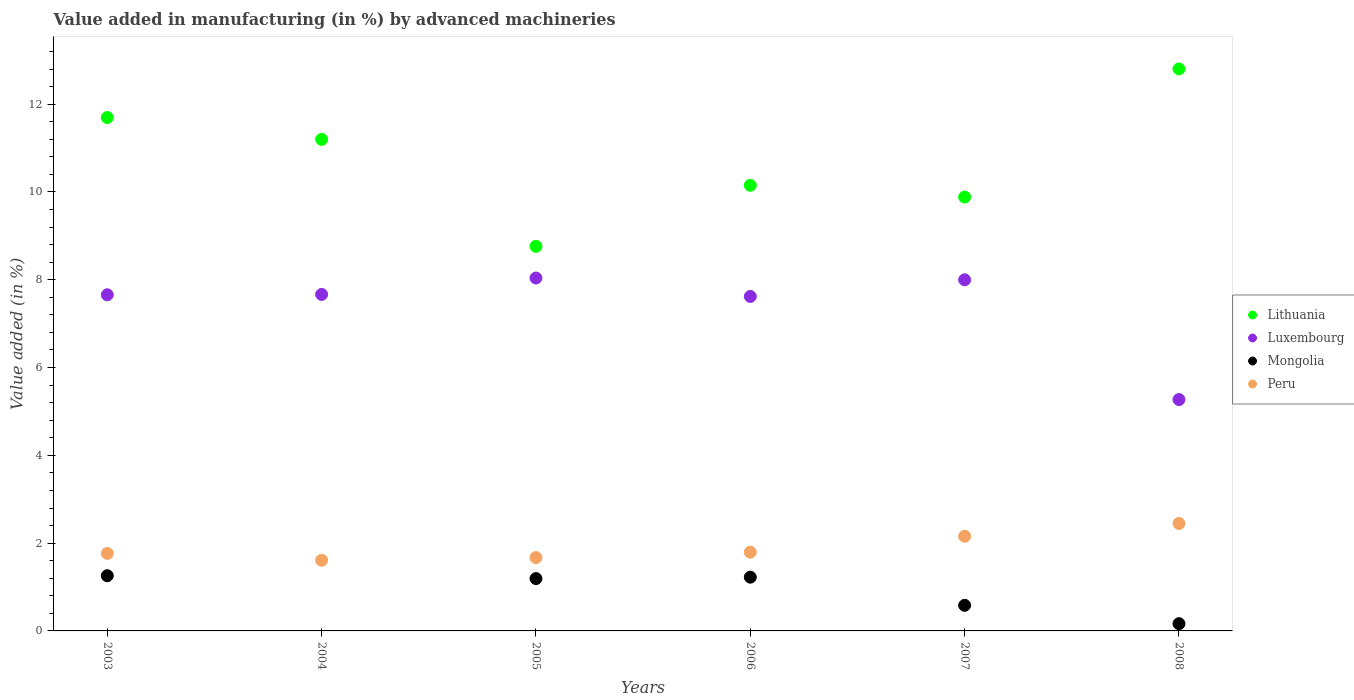What is the percentage of value added in manufacturing by advanced machineries in Lithuania in 2007?
Provide a short and direct response. 9.88. Across all years, what is the maximum percentage of value added in manufacturing by advanced machineries in Mongolia?
Offer a very short reply. 1.26. Across all years, what is the minimum percentage of value added in manufacturing by advanced machineries in Peru?
Make the answer very short. 1.61. In which year was the percentage of value added in manufacturing by advanced machineries in Peru maximum?
Make the answer very short. 2008. What is the total percentage of value added in manufacturing by advanced machineries in Mongolia in the graph?
Give a very brief answer. 4.42. What is the difference between the percentage of value added in manufacturing by advanced machineries in Luxembourg in 2004 and that in 2005?
Keep it short and to the point. -0.37. What is the difference between the percentage of value added in manufacturing by advanced machineries in Mongolia in 2006 and the percentage of value added in manufacturing by advanced machineries in Peru in 2007?
Your answer should be compact. -0.93. What is the average percentage of value added in manufacturing by advanced machineries in Peru per year?
Give a very brief answer. 1.91. In the year 2005, what is the difference between the percentage of value added in manufacturing by advanced machineries in Luxembourg and percentage of value added in manufacturing by advanced machineries in Lithuania?
Make the answer very short. -0.72. In how many years, is the percentage of value added in manufacturing by advanced machineries in Luxembourg greater than 7.6 %?
Offer a terse response. 5. What is the ratio of the percentage of value added in manufacturing by advanced machineries in Luxembourg in 2004 to that in 2005?
Keep it short and to the point. 0.95. Is the percentage of value added in manufacturing by advanced machineries in Mongolia in 2005 less than that in 2006?
Make the answer very short. Yes. Is the difference between the percentage of value added in manufacturing by advanced machineries in Luxembourg in 2003 and 2005 greater than the difference between the percentage of value added in manufacturing by advanced machineries in Lithuania in 2003 and 2005?
Provide a succinct answer. No. What is the difference between the highest and the second highest percentage of value added in manufacturing by advanced machineries in Luxembourg?
Offer a terse response. 0.04. What is the difference between the highest and the lowest percentage of value added in manufacturing by advanced machineries in Mongolia?
Provide a succinct answer. 1.26. Is the percentage of value added in manufacturing by advanced machineries in Peru strictly greater than the percentage of value added in manufacturing by advanced machineries in Lithuania over the years?
Your response must be concise. No. What is the difference between two consecutive major ticks on the Y-axis?
Offer a terse response. 2. Does the graph contain any zero values?
Ensure brevity in your answer.  Yes. Where does the legend appear in the graph?
Your answer should be very brief. Center right. How are the legend labels stacked?
Give a very brief answer. Vertical. What is the title of the graph?
Make the answer very short. Value added in manufacturing (in %) by advanced machineries. Does "Pacific island small states" appear as one of the legend labels in the graph?
Make the answer very short. No. What is the label or title of the X-axis?
Give a very brief answer. Years. What is the label or title of the Y-axis?
Your answer should be compact. Value added (in %). What is the Value added (in %) of Lithuania in 2003?
Your response must be concise. 11.7. What is the Value added (in %) in Luxembourg in 2003?
Ensure brevity in your answer.  7.66. What is the Value added (in %) in Mongolia in 2003?
Offer a very short reply. 1.26. What is the Value added (in %) in Peru in 2003?
Keep it short and to the point. 1.77. What is the Value added (in %) in Lithuania in 2004?
Provide a short and direct response. 11.2. What is the Value added (in %) in Luxembourg in 2004?
Your answer should be compact. 7.67. What is the Value added (in %) of Peru in 2004?
Your response must be concise. 1.61. What is the Value added (in %) in Lithuania in 2005?
Your answer should be compact. 8.76. What is the Value added (in %) of Luxembourg in 2005?
Make the answer very short. 8.04. What is the Value added (in %) in Mongolia in 2005?
Provide a short and direct response. 1.19. What is the Value added (in %) of Peru in 2005?
Ensure brevity in your answer.  1.67. What is the Value added (in %) in Lithuania in 2006?
Provide a short and direct response. 10.15. What is the Value added (in %) of Luxembourg in 2006?
Offer a very short reply. 7.62. What is the Value added (in %) in Mongolia in 2006?
Offer a very short reply. 1.22. What is the Value added (in %) in Peru in 2006?
Your answer should be very brief. 1.79. What is the Value added (in %) in Lithuania in 2007?
Your response must be concise. 9.88. What is the Value added (in %) in Luxembourg in 2007?
Offer a terse response. 8. What is the Value added (in %) in Mongolia in 2007?
Offer a terse response. 0.58. What is the Value added (in %) in Peru in 2007?
Your answer should be compact. 2.16. What is the Value added (in %) of Lithuania in 2008?
Keep it short and to the point. 12.8. What is the Value added (in %) of Luxembourg in 2008?
Give a very brief answer. 5.27. What is the Value added (in %) of Mongolia in 2008?
Make the answer very short. 0.17. What is the Value added (in %) of Peru in 2008?
Offer a terse response. 2.45. Across all years, what is the maximum Value added (in %) of Lithuania?
Make the answer very short. 12.8. Across all years, what is the maximum Value added (in %) in Luxembourg?
Keep it short and to the point. 8.04. Across all years, what is the maximum Value added (in %) in Mongolia?
Your answer should be compact. 1.26. Across all years, what is the maximum Value added (in %) in Peru?
Provide a short and direct response. 2.45. Across all years, what is the minimum Value added (in %) in Lithuania?
Offer a very short reply. 8.76. Across all years, what is the minimum Value added (in %) of Luxembourg?
Ensure brevity in your answer.  5.27. Across all years, what is the minimum Value added (in %) in Mongolia?
Provide a short and direct response. 0. Across all years, what is the minimum Value added (in %) in Peru?
Your answer should be compact. 1.61. What is the total Value added (in %) of Lithuania in the graph?
Offer a very short reply. 64.49. What is the total Value added (in %) in Luxembourg in the graph?
Keep it short and to the point. 44.25. What is the total Value added (in %) in Mongolia in the graph?
Your response must be concise. 4.42. What is the total Value added (in %) of Peru in the graph?
Your answer should be compact. 11.45. What is the difference between the Value added (in %) in Lithuania in 2003 and that in 2004?
Give a very brief answer. 0.5. What is the difference between the Value added (in %) of Luxembourg in 2003 and that in 2004?
Give a very brief answer. -0.01. What is the difference between the Value added (in %) in Peru in 2003 and that in 2004?
Your answer should be compact. 0.16. What is the difference between the Value added (in %) in Lithuania in 2003 and that in 2005?
Your response must be concise. 2.93. What is the difference between the Value added (in %) of Luxembourg in 2003 and that in 2005?
Give a very brief answer. -0.38. What is the difference between the Value added (in %) in Mongolia in 2003 and that in 2005?
Provide a succinct answer. 0.07. What is the difference between the Value added (in %) in Peru in 2003 and that in 2005?
Give a very brief answer. 0.09. What is the difference between the Value added (in %) of Lithuania in 2003 and that in 2006?
Provide a short and direct response. 1.54. What is the difference between the Value added (in %) in Luxembourg in 2003 and that in 2006?
Ensure brevity in your answer.  0.04. What is the difference between the Value added (in %) in Mongolia in 2003 and that in 2006?
Your response must be concise. 0.03. What is the difference between the Value added (in %) in Peru in 2003 and that in 2006?
Offer a very short reply. -0.03. What is the difference between the Value added (in %) of Lithuania in 2003 and that in 2007?
Offer a terse response. 1.81. What is the difference between the Value added (in %) in Luxembourg in 2003 and that in 2007?
Your answer should be very brief. -0.34. What is the difference between the Value added (in %) in Mongolia in 2003 and that in 2007?
Your answer should be very brief. 0.67. What is the difference between the Value added (in %) of Peru in 2003 and that in 2007?
Your response must be concise. -0.39. What is the difference between the Value added (in %) in Lithuania in 2003 and that in 2008?
Ensure brevity in your answer.  -1.11. What is the difference between the Value added (in %) of Luxembourg in 2003 and that in 2008?
Provide a succinct answer. 2.39. What is the difference between the Value added (in %) in Mongolia in 2003 and that in 2008?
Give a very brief answer. 1.09. What is the difference between the Value added (in %) of Peru in 2003 and that in 2008?
Make the answer very short. -0.68. What is the difference between the Value added (in %) in Lithuania in 2004 and that in 2005?
Provide a short and direct response. 2.44. What is the difference between the Value added (in %) in Luxembourg in 2004 and that in 2005?
Provide a succinct answer. -0.37. What is the difference between the Value added (in %) of Peru in 2004 and that in 2005?
Give a very brief answer. -0.06. What is the difference between the Value added (in %) in Lithuania in 2004 and that in 2006?
Ensure brevity in your answer.  1.05. What is the difference between the Value added (in %) in Luxembourg in 2004 and that in 2006?
Your answer should be compact. 0.05. What is the difference between the Value added (in %) of Peru in 2004 and that in 2006?
Give a very brief answer. -0.18. What is the difference between the Value added (in %) of Lithuania in 2004 and that in 2007?
Your answer should be compact. 1.31. What is the difference between the Value added (in %) of Luxembourg in 2004 and that in 2007?
Provide a succinct answer. -0.33. What is the difference between the Value added (in %) of Peru in 2004 and that in 2007?
Offer a terse response. -0.55. What is the difference between the Value added (in %) of Lithuania in 2004 and that in 2008?
Ensure brevity in your answer.  -1.6. What is the difference between the Value added (in %) of Luxembourg in 2004 and that in 2008?
Offer a terse response. 2.39. What is the difference between the Value added (in %) of Peru in 2004 and that in 2008?
Provide a succinct answer. -0.84. What is the difference between the Value added (in %) of Lithuania in 2005 and that in 2006?
Make the answer very short. -1.39. What is the difference between the Value added (in %) in Luxembourg in 2005 and that in 2006?
Your answer should be compact. 0.42. What is the difference between the Value added (in %) of Mongolia in 2005 and that in 2006?
Offer a terse response. -0.03. What is the difference between the Value added (in %) in Peru in 2005 and that in 2006?
Provide a short and direct response. -0.12. What is the difference between the Value added (in %) of Lithuania in 2005 and that in 2007?
Your answer should be compact. -1.12. What is the difference between the Value added (in %) of Luxembourg in 2005 and that in 2007?
Offer a very short reply. 0.04. What is the difference between the Value added (in %) in Mongolia in 2005 and that in 2007?
Offer a terse response. 0.61. What is the difference between the Value added (in %) in Peru in 2005 and that in 2007?
Your answer should be very brief. -0.49. What is the difference between the Value added (in %) in Lithuania in 2005 and that in 2008?
Your answer should be very brief. -4.04. What is the difference between the Value added (in %) of Luxembourg in 2005 and that in 2008?
Your answer should be compact. 2.77. What is the difference between the Value added (in %) in Mongolia in 2005 and that in 2008?
Ensure brevity in your answer.  1.03. What is the difference between the Value added (in %) in Peru in 2005 and that in 2008?
Make the answer very short. -0.78. What is the difference between the Value added (in %) in Lithuania in 2006 and that in 2007?
Your answer should be very brief. 0.27. What is the difference between the Value added (in %) in Luxembourg in 2006 and that in 2007?
Give a very brief answer. -0.38. What is the difference between the Value added (in %) of Mongolia in 2006 and that in 2007?
Your response must be concise. 0.64. What is the difference between the Value added (in %) in Peru in 2006 and that in 2007?
Ensure brevity in your answer.  -0.36. What is the difference between the Value added (in %) of Lithuania in 2006 and that in 2008?
Keep it short and to the point. -2.65. What is the difference between the Value added (in %) in Luxembourg in 2006 and that in 2008?
Give a very brief answer. 2.35. What is the difference between the Value added (in %) in Mongolia in 2006 and that in 2008?
Offer a very short reply. 1.06. What is the difference between the Value added (in %) in Peru in 2006 and that in 2008?
Ensure brevity in your answer.  -0.65. What is the difference between the Value added (in %) of Lithuania in 2007 and that in 2008?
Give a very brief answer. -2.92. What is the difference between the Value added (in %) in Luxembourg in 2007 and that in 2008?
Your response must be concise. 2.73. What is the difference between the Value added (in %) in Mongolia in 2007 and that in 2008?
Your answer should be compact. 0.42. What is the difference between the Value added (in %) of Peru in 2007 and that in 2008?
Keep it short and to the point. -0.29. What is the difference between the Value added (in %) in Lithuania in 2003 and the Value added (in %) in Luxembourg in 2004?
Offer a terse response. 4.03. What is the difference between the Value added (in %) of Lithuania in 2003 and the Value added (in %) of Peru in 2004?
Keep it short and to the point. 10.09. What is the difference between the Value added (in %) in Luxembourg in 2003 and the Value added (in %) in Peru in 2004?
Offer a very short reply. 6.05. What is the difference between the Value added (in %) of Mongolia in 2003 and the Value added (in %) of Peru in 2004?
Offer a terse response. -0.35. What is the difference between the Value added (in %) in Lithuania in 2003 and the Value added (in %) in Luxembourg in 2005?
Your response must be concise. 3.66. What is the difference between the Value added (in %) of Lithuania in 2003 and the Value added (in %) of Mongolia in 2005?
Your answer should be compact. 10.5. What is the difference between the Value added (in %) of Lithuania in 2003 and the Value added (in %) of Peru in 2005?
Make the answer very short. 10.02. What is the difference between the Value added (in %) in Luxembourg in 2003 and the Value added (in %) in Mongolia in 2005?
Provide a short and direct response. 6.47. What is the difference between the Value added (in %) of Luxembourg in 2003 and the Value added (in %) of Peru in 2005?
Offer a very short reply. 5.99. What is the difference between the Value added (in %) of Mongolia in 2003 and the Value added (in %) of Peru in 2005?
Your response must be concise. -0.41. What is the difference between the Value added (in %) in Lithuania in 2003 and the Value added (in %) in Luxembourg in 2006?
Provide a short and direct response. 4.08. What is the difference between the Value added (in %) of Lithuania in 2003 and the Value added (in %) of Mongolia in 2006?
Your answer should be compact. 10.47. What is the difference between the Value added (in %) in Lithuania in 2003 and the Value added (in %) in Peru in 2006?
Your response must be concise. 9.9. What is the difference between the Value added (in %) in Luxembourg in 2003 and the Value added (in %) in Mongolia in 2006?
Your response must be concise. 6.43. What is the difference between the Value added (in %) in Luxembourg in 2003 and the Value added (in %) in Peru in 2006?
Your answer should be very brief. 5.86. What is the difference between the Value added (in %) of Mongolia in 2003 and the Value added (in %) of Peru in 2006?
Provide a short and direct response. -0.54. What is the difference between the Value added (in %) of Lithuania in 2003 and the Value added (in %) of Luxembourg in 2007?
Make the answer very short. 3.7. What is the difference between the Value added (in %) of Lithuania in 2003 and the Value added (in %) of Mongolia in 2007?
Ensure brevity in your answer.  11.11. What is the difference between the Value added (in %) of Lithuania in 2003 and the Value added (in %) of Peru in 2007?
Offer a terse response. 9.54. What is the difference between the Value added (in %) of Luxembourg in 2003 and the Value added (in %) of Mongolia in 2007?
Provide a succinct answer. 7.07. What is the difference between the Value added (in %) of Luxembourg in 2003 and the Value added (in %) of Peru in 2007?
Your answer should be very brief. 5.5. What is the difference between the Value added (in %) of Mongolia in 2003 and the Value added (in %) of Peru in 2007?
Your answer should be very brief. -0.9. What is the difference between the Value added (in %) of Lithuania in 2003 and the Value added (in %) of Luxembourg in 2008?
Give a very brief answer. 6.42. What is the difference between the Value added (in %) in Lithuania in 2003 and the Value added (in %) in Mongolia in 2008?
Your answer should be very brief. 11.53. What is the difference between the Value added (in %) of Lithuania in 2003 and the Value added (in %) of Peru in 2008?
Keep it short and to the point. 9.25. What is the difference between the Value added (in %) of Luxembourg in 2003 and the Value added (in %) of Mongolia in 2008?
Ensure brevity in your answer.  7.49. What is the difference between the Value added (in %) of Luxembourg in 2003 and the Value added (in %) of Peru in 2008?
Keep it short and to the point. 5.21. What is the difference between the Value added (in %) of Mongolia in 2003 and the Value added (in %) of Peru in 2008?
Your answer should be compact. -1.19. What is the difference between the Value added (in %) in Lithuania in 2004 and the Value added (in %) in Luxembourg in 2005?
Your answer should be compact. 3.16. What is the difference between the Value added (in %) of Lithuania in 2004 and the Value added (in %) of Mongolia in 2005?
Your response must be concise. 10.01. What is the difference between the Value added (in %) of Lithuania in 2004 and the Value added (in %) of Peru in 2005?
Your response must be concise. 9.53. What is the difference between the Value added (in %) of Luxembourg in 2004 and the Value added (in %) of Mongolia in 2005?
Make the answer very short. 6.47. What is the difference between the Value added (in %) of Luxembourg in 2004 and the Value added (in %) of Peru in 2005?
Give a very brief answer. 5.99. What is the difference between the Value added (in %) of Lithuania in 2004 and the Value added (in %) of Luxembourg in 2006?
Ensure brevity in your answer.  3.58. What is the difference between the Value added (in %) in Lithuania in 2004 and the Value added (in %) in Mongolia in 2006?
Provide a short and direct response. 9.97. What is the difference between the Value added (in %) in Lithuania in 2004 and the Value added (in %) in Peru in 2006?
Make the answer very short. 9.4. What is the difference between the Value added (in %) of Luxembourg in 2004 and the Value added (in %) of Mongolia in 2006?
Your response must be concise. 6.44. What is the difference between the Value added (in %) of Luxembourg in 2004 and the Value added (in %) of Peru in 2006?
Offer a terse response. 5.87. What is the difference between the Value added (in %) in Lithuania in 2004 and the Value added (in %) in Luxembourg in 2007?
Your answer should be very brief. 3.2. What is the difference between the Value added (in %) in Lithuania in 2004 and the Value added (in %) in Mongolia in 2007?
Make the answer very short. 10.61. What is the difference between the Value added (in %) of Lithuania in 2004 and the Value added (in %) of Peru in 2007?
Keep it short and to the point. 9.04. What is the difference between the Value added (in %) of Luxembourg in 2004 and the Value added (in %) of Mongolia in 2007?
Make the answer very short. 7.08. What is the difference between the Value added (in %) in Luxembourg in 2004 and the Value added (in %) in Peru in 2007?
Provide a short and direct response. 5.51. What is the difference between the Value added (in %) in Lithuania in 2004 and the Value added (in %) in Luxembourg in 2008?
Your answer should be compact. 5.93. What is the difference between the Value added (in %) in Lithuania in 2004 and the Value added (in %) in Mongolia in 2008?
Give a very brief answer. 11.03. What is the difference between the Value added (in %) in Lithuania in 2004 and the Value added (in %) in Peru in 2008?
Your response must be concise. 8.75. What is the difference between the Value added (in %) in Luxembourg in 2004 and the Value added (in %) in Mongolia in 2008?
Keep it short and to the point. 7.5. What is the difference between the Value added (in %) of Luxembourg in 2004 and the Value added (in %) of Peru in 2008?
Give a very brief answer. 5.22. What is the difference between the Value added (in %) of Lithuania in 2005 and the Value added (in %) of Luxembourg in 2006?
Give a very brief answer. 1.14. What is the difference between the Value added (in %) of Lithuania in 2005 and the Value added (in %) of Mongolia in 2006?
Ensure brevity in your answer.  7.54. What is the difference between the Value added (in %) of Lithuania in 2005 and the Value added (in %) of Peru in 2006?
Your response must be concise. 6.97. What is the difference between the Value added (in %) in Luxembourg in 2005 and the Value added (in %) in Mongolia in 2006?
Offer a terse response. 6.81. What is the difference between the Value added (in %) of Luxembourg in 2005 and the Value added (in %) of Peru in 2006?
Your response must be concise. 6.25. What is the difference between the Value added (in %) of Mongolia in 2005 and the Value added (in %) of Peru in 2006?
Offer a very short reply. -0.6. What is the difference between the Value added (in %) of Lithuania in 2005 and the Value added (in %) of Luxembourg in 2007?
Make the answer very short. 0.76. What is the difference between the Value added (in %) in Lithuania in 2005 and the Value added (in %) in Mongolia in 2007?
Give a very brief answer. 8.18. What is the difference between the Value added (in %) in Lithuania in 2005 and the Value added (in %) in Peru in 2007?
Ensure brevity in your answer.  6.6. What is the difference between the Value added (in %) of Luxembourg in 2005 and the Value added (in %) of Mongolia in 2007?
Offer a terse response. 7.46. What is the difference between the Value added (in %) in Luxembourg in 2005 and the Value added (in %) in Peru in 2007?
Your answer should be compact. 5.88. What is the difference between the Value added (in %) in Mongolia in 2005 and the Value added (in %) in Peru in 2007?
Offer a very short reply. -0.96. What is the difference between the Value added (in %) in Lithuania in 2005 and the Value added (in %) in Luxembourg in 2008?
Provide a succinct answer. 3.49. What is the difference between the Value added (in %) in Lithuania in 2005 and the Value added (in %) in Mongolia in 2008?
Make the answer very short. 8.6. What is the difference between the Value added (in %) of Lithuania in 2005 and the Value added (in %) of Peru in 2008?
Your answer should be compact. 6.31. What is the difference between the Value added (in %) of Luxembourg in 2005 and the Value added (in %) of Mongolia in 2008?
Provide a short and direct response. 7.87. What is the difference between the Value added (in %) of Luxembourg in 2005 and the Value added (in %) of Peru in 2008?
Offer a terse response. 5.59. What is the difference between the Value added (in %) in Mongolia in 2005 and the Value added (in %) in Peru in 2008?
Your response must be concise. -1.26. What is the difference between the Value added (in %) in Lithuania in 2006 and the Value added (in %) in Luxembourg in 2007?
Your answer should be very brief. 2.15. What is the difference between the Value added (in %) of Lithuania in 2006 and the Value added (in %) of Mongolia in 2007?
Your answer should be very brief. 9.57. What is the difference between the Value added (in %) in Lithuania in 2006 and the Value added (in %) in Peru in 2007?
Provide a short and direct response. 7.99. What is the difference between the Value added (in %) of Luxembourg in 2006 and the Value added (in %) of Mongolia in 2007?
Ensure brevity in your answer.  7.04. What is the difference between the Value added (in %) of Luxembourg in 2006 and the Value added (in %) of Peru in 2007?
Ensure brevity in your answer.  5.46. What is the difference between the Value added (in %) in Mongolia in 2006 and the Value added (in %) in Peru in 2007?
Your response must be concise. -0.93. What is the difference between the Value added (in %) of Lithuania in 2006 and the Value added (in %) of Luxembourg in 2008?
Provide a short and direct response. 4.88. What is the difference between the Value added (in %) of Lithuania in 2006 and the Value added (in %) of Mongolia in 2008?
Give a very brief answer. 9.99. What is the difference between the Value added (in %) of Lithuania in 2006 and the Value added (in %) of Peru in 2008?
Your answer should be very brief. 7.7. What is the difference between the Value added (in %) in Luxembourg in 2006 and the Value added (in %) in Mongolia in 2008?
Your answer should be very brief. 7.45. What is the difference between the Value added (in %) of Luxembourg in 2006 and the Value added (in %) of Peru in 2008?
Keep it short and to the point. 5.17. What is the difference between the Value added (in %) in Mongolia in 2006 and the Value added (in %) in Peru in 2008?
Your answer should be compact. -1.22. What is the difference between the Value added (in %) of Lithuania in 2007 and the Value added (in %) of Luxembourg in 2008?
Provide a succinct answer. 4.61. What is the difference between the Value added (in %) of Lithuania in 2007 and the Value added (in %) of Mongolia in 2008?
Your answer should be compact. 9.72. What is the difference between the Value added (in %) in Lithuania in 2007 and the Value added (in %) in Peru in 2008?
Give a very brief answer. 7.44. What is the difference between the Value added (in %) in Luxembourg in 2007 and the Value added (in %) in Mongolia in 2008?
Offer a terse response. 7.83. What is the difference between the Value added (in %) in Luxembourg in 2007 and the Value added (in %) in Peru in 2008?
Your answer should be very brief. 5.55. What is the difference between the Value added (in %) in Mongolia in 2007 and the Value added (in %) in Peru in 2008?
Offer a very short reply. -1.86. What is the average Value added (in %) in Lithuania per year?
Provide a succinct answer. 10.75. What is the average Value added (in %) of Luxembourg per year?
Provide a short and direct response. 7.38. What is the average Value added (in %) of Mongolia per year?
Give a very brief answer. 0.74. What is the average Value added (in %) in Peru per year?
Keep it short and to the point. 1.91. In the year 2003, what is the difference between the Value added (in %) of Lithuania and Value added (in %) of Luxembourg?
Your response must be concise. 4.04. In the year 2003, what is the difference between the Value added (in %) in Lithuania and Value added (in %) in Mongolia?
Give a very brief answer. 10.44. In the year 2003, what is the difference between the Value added (in %) of Lithuania and Value added (in %) of Peru?
Offer a terse response. 9.93. In the year 2003, what is the difference between the Value added (in %) of Luxembourg and Value added (in %) of Mongolia?
Provide a short and direct response. 6.4. In the year 2003, what is the difference between the Value added (in %) of Luxembourg and Value added (in %) of Peru?
Provide a succinct answer. 5.89. In the year 2003, what is the difference between the Value added (in %) of Mongolia and Value added (in %) of Peru?
Keep it short and to the point. -0.51. In the year 2004, what is the difference between the Value added (in %) of Lithuania and Value added (in %) of Luxembourg?
Your response must be concise. 3.53. In the year 2004, what is the difference between the Value added (in %) in Lithuania and Value added (in %) in Peru?
Your response must be concise. 9.59. In the year 2004, what is the difference between the Value added (in %) in Luxembourg and Value added (in %) in Peru?
Make the answer very short. 6.06. In the year 2005, what is the difference between the Value added (in %) in Lithuania and Value added (in %) in Luxembourg?
Give a very brief answer. 0.72. In the year 2005, what is the difference between the Value added (in %) in Lithuania and Value added (in %) in Mongolia?
Your answer should be very brief. 7.57. In the year 2005, what is the difference between the Value added (in %) in Lithuania and Value added (in %) in Peru?
Ensure brevity in your answer.  7.09. In the year 2005, what is the difference between the Value added (in %) in Luxembourg and Value added (in %) in Mongolia?
Provide a short and direct response. 6.85. In the year 2005, what is the difference between the Value added (in %) of Luxembourg and Value added (in %) of Peru?
Provide a short and direct response. 6.37. In the year 2005, what is the difference between the Value added (in %) of Mongolia and Value added (in %) of Peru?
Provide a succinct answer. -0.48. In the year 2006, what is the difference between the Value added (in %) of Lithuania and Value added (in %) of Luxembourg?
Provide a succinct answer. 2.53. In the year 2006, what is the difference between the Value added (in %) of Lithuania and Value added (in %) of Mongolia?
Provide a short and direct response. 8.93. In the year 2006, what is the difference between the Value added (in %) in Lithuania and Value added (in %) in Peru?
Give a very brief answer. 8.36. In the year 2006, what is the difference between the Value added (in %) in Luxembourg and Value added (in %) in Mongolia?
Your answer should be compact. 6.4. In the year 2006, what is the difference between the Value added (in %) in Luxembourg and Value added (in %) in Peru?
Your answer should be very brief. 5.83. In the year 2006, what is the difference between the Value added (in %) of Mongolia and Value added (in %) of Peru?
Provide a succinct answer. -0.57. In the year 2007, what is the difference between the Value added (in %) in Lithuania and Value added (in %) in Luxembourg?
Offer a terse response. 1.88. In the year 2007, what is the difference between the Value added (in %) of Lithuania and Value added (in %) of Mongolia?
Keep it short and to the point. 9.3. In the year 2007, what is the difference between the Value added (in %) of Lithuania and Value added (in %) of Peru?
Offer a terse response. 7.73. In the year 2007, what is the difference between the Value added (in %) in Luxembourg and Value added (in %) in Mongolia?
Provide a short and direct response. 7.42. In the year 2007, what is the difference between the Value added (in %) of Luxembourg and Value added (in %) of Peru?
Offer a very short reply. 5.84. In the year 2007, what is the difference between the Value added (in %) in Mongolia and Value added (in %) in Peru?
Ensure brevity in your answer.  -1.57. In the year 2008, what is the difference between the Value added (in %) of Lithuania and Value added (in %) of Luxembourg?
Your response must be concise. 7.53. In the year 2008, what is the difference between the Value added (in %) of Lithuania and Value added (in %) of Mongolia?
Provide a succinct answer. 12.64. In the year 2008, what is the difference between the Value added (in %) of Lithuania and Value added (in %) of Peru?
Your response must be concise. 10.35. In the year 2008, what is the difference between the Value added (in %) in Luxembourg and Value added (in %) in Mongolia?
Provide a succinct answer. 5.11. In the year 2008, what is the difference between the Value added (in %) in Luxembourg and Value added (in %) in Peru?
Provide a short and direct response. 2.82. In the year 2008, what is the difference between the Value added (in %) in Mongolia and Value added (in %) in Peru?
Make the answer very short. -2.28. What is the ratio of the Value added (in %) in Lithuania in 2003 to that in 2004?
Offer a very short reply. 1.04. What is the ratio of the Value added (in %) in Luxembourg in 2003 to that in 2004?
Give a very brief answer. 1. What is the ratio of the Value added (in %) of Peru in 2003 to that in 2004?
Ensure brevity in your answer.  1.1. What is the ratio of the Value added (in %) in Lithuania in 2003 to that in 2005?
Your response must be concise. 1.33. What is the ratio of the Value added (in %) of Luxembourg in 2003 to that in 2005?
Your answer should be compact. 0.95. What is the ratio of the Value added (in %) of Mongolia in 2003 to that in 2005?
Your answer should be very brief. 1.05. What is the ratio of the Value added (in %) in Peru in 2003 to that in 2005?
Your answer should be compact. 1.06. What is the ratio of the Value added (in %) in Lithuania in 2003 to that in 2006?
Offer a terse response. 1.15. What is the ratio of the Value added (in %) in Mongolia in 2003 to that in 2006?
Offer a very short reply. 1.03. What is the ratio of the Value added (in %) of Peru in 2003 to that in 2006?
Your answer should be very brief. 0.98. What is the ratio of the Value added (in %) of Lithuania in 2003 to that in 2007?
Make the answer very short. 1.18. What is the ratio of the Value added (in %) in Luxembourg in 2003 to that in 2007?
Your response must be concise. 0.96. What is the ratio of the Value added (in %) of Mongolia in 2003 to that in 2007?
Ensure brevity in your answer.  2.16. What is the ratio of the Value added (in %) in Peru in 2003 to that in 2007?
Make the answer very short. 0.82. What is the ratio of the Value added (in %) in Lithuania in 2003 to that in 2008?
Make the answer very short. 0.91. What is the ratio of the Value added (in %) in Luxembourg in 2003 to that in 2008?
Offer a very short reply. 1.45. What is the ratio of the Value added (in %) in Mongolia in 2003 to that in 2008?
Keep it short and to the point. 7.62. What is the ratio of the Value added (in %) in Peru in 2003 to that in 2008?
Keep it short and to the point. 0.72. What is the ratio of the Value added (in %) in Lithuania in 2004 to that in 2005?
Ensure brevity in your answer.  1.28. What is the ratio of the Value added (in %) of Luxembourg in 2004 to that in 2005?
Provide a short and direct response. 0.95. What is the ratio of the Value added (in %) of Peru in 2004 to that in 2005?
Provide a succinct answer. 0.96. What is the ratio of the Value added (in %) in Lithuania in 2004 to that in 2006?
Ensure brevity in your answer.  1.1. What is the ratio of the Value added (in %) of Luxembourg in 2004 to that in 2006?
Offer a terse response. 1.01. What is the ratio of the Value added (in %) of Peru in 2004 to that in 2006?
Give a very brief answer. 0.9. What is the ratio of the Value added (in %) of Lithuania in 2004 to that in 2007?
Ensure brevity in your answer.  1.13. What is the ratio of the Value added (in %) in Peru in 2004 to that in 2007?
Your answer should be very brief. 0.75. What is the ratio of the Value added (in %) in Lithuania in 2004 to that in 2008?
Your answer should be compact. 0.87. What is the ratio of the Value added (in %) of Luxembourg in 2004 to that in 2008?
Ensure brevity in your answer.  1.45. What is the ratio of the Value added (in %) in Peru in 2004 to that in 2008?
Offer a terse response. 0.66. What is the ratio of the Value added (in %) in Lithuania in 2005 to that in 2006?
Keep it short and to the point. 0.86. What is the ratio of the Value added (in %) in Luxembourg in 2005 to that in 2006?
Provide a short and direct response. 1.05. What is the ratio of the Value added (in %) in Mongolia in 2005 to that in 2006?
Provide a succinct answer. 0.97. What is the ratio of the Value added (in %) in Peru in 2005 to that in 2006?
Provide a succinct answer. 0.93. What is the ratio of the Value added (in %) of Lithuania in 2005 to that in 2007?
Your answer should be very brief. 0.89. What is the ratio of the Value added (in %) in Luxembourg in 2005 to that in 2007?
Offer a very short reply. 1. What is the ratio of the Value added (in %) of Mongolia in 2005 to that in 2007?
Give a very brief answer. 2.04. What is the ratio of the Value added (in %) of Peru in 2005 to that in 2007?
Your answer should be very brief. 0.77. What is the ratio of the Value added (in %) of Lithuania in 2005 to that in 2008?
Give a very brief answer. 0.68. What is the ratio of the Value added (in %) of Luxembourg in 2005 to that in 2008?
Give a very brief answer. 1.53. What is the ratio of the Value added (in %) in Mongolia in 2005 to that in 2008?
Keep it short and to the point. 7.23. What is the ratio of the Value added (in %) of Peru in 2005 to that in 2008?
Provide a succinct answer. 0.68. What is the ratio of the Value added (in %) of Lithuania in 2006 to that in 2007?
Ensure brevity in your answer.  1.03. What is the ratio of the Value added (in %) of Luxembourg in 2006 to that in 2007?
Your response must be concise. 0.95. What is the ratio of the Value added (in %) of Mongolia in 2006 to that in 2007?
Provide a short and direct response. 2.1. What is the ratio of the Value added (in %) of Peru in 2006 to that in 2007?
Your response must be concise. 0.83. What is the ratio of the Value added (in %) in Lithuania in 2006 to that in 2008?
Your answer should be compact. 0.79. What is the ratio of the Value added (in %) in Luxembourg in 2006 to that in 2008?
Offer a very short reply. 1.45. What is the ratio of the Value added (in %) of Mongolia in 2006 to that in 2008?
Keep it short and to the point. 7.42. What is the ratio of the Value added (in %) in Peru in 2006 to that in 2008?
Offer a very short reply. 0.73. What is the ratio of the Value added (in %) of Lithuania in 2007 to that in 2008?
Keep it short and to the point. 0.77. What is the ratio of the Value added (in %) in Luxembourg in 2007 to that in 2008?
Ensure brevity in your answer.  1.52. What is the ratio of the Value added (in %) of Mongolia in 2007 to that in 2008?
Offer a very short reply. 3.54. What is the ratio of the Value added (in %) in Peru in 2007 to that in 2008?
Your answer should be compact. 0.88. What is the difference between the highest and the second highest Value added (in %) of Lithuania?
Offer a very short reply. 1.11. What is the difference between the highest and the second highest Value added (in %) in Luxembourg?
Your answer should be very brief. 0.04. What is the difference between the highest and the second highest Value added (in %) in Peru?
Make the answer very short. 0.29. What is the difference between the highest and the lowest Value added (in %) in Lithuania?
Ensure brevity in your answer.  4.04. What is the difference between the highest and the lowest Value added (in %) of Luxembourg?
Your answer should be very brief. 2.77. What is the difference between the highest and the lowest Value added (in %) in Mongolia?
Ensure brevity in your answer.  1.26. What is the difference between the highest and the lowest Value added (in %) in Peru?
Your answer should be very brief. 0.84. 